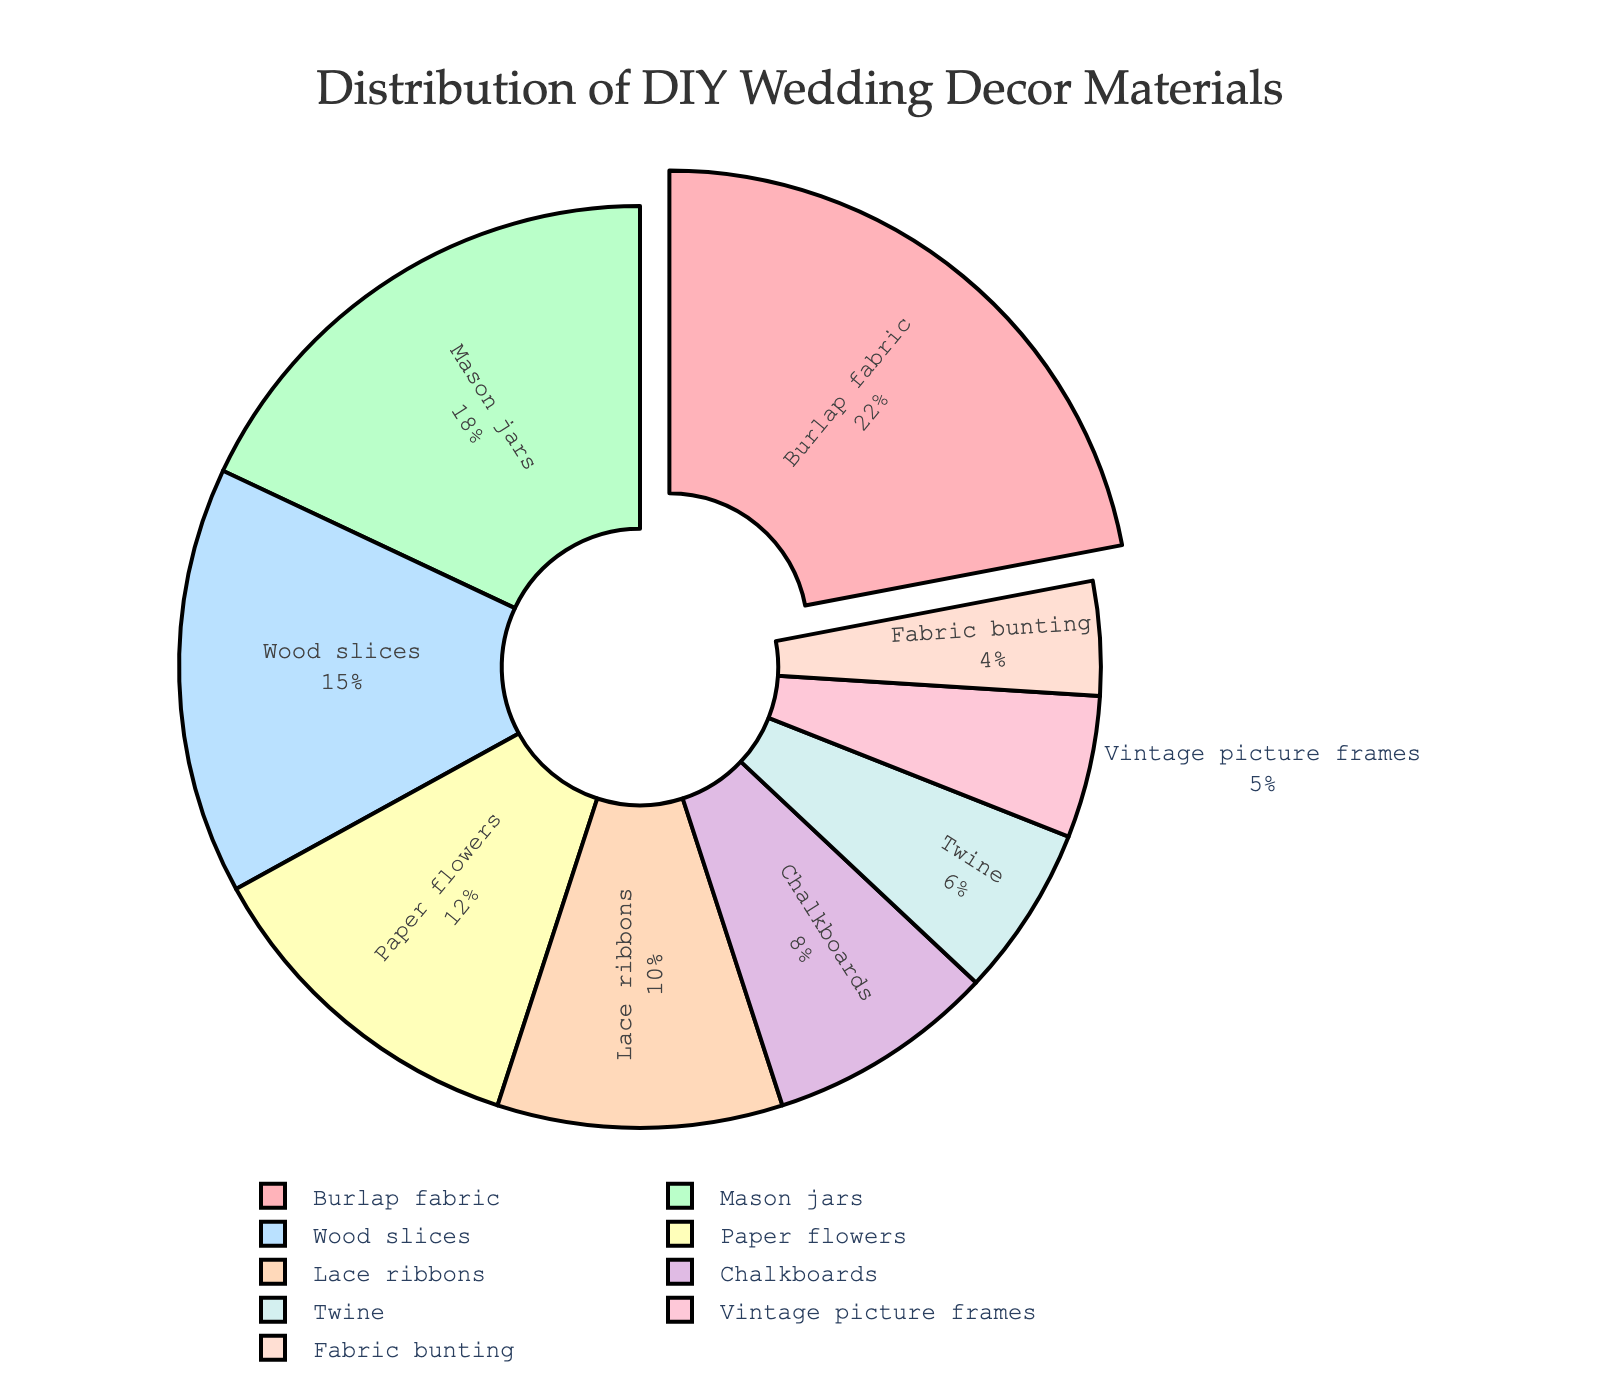What's the most popular DIY wedding decor material? The segment with the highest percentage represents the most popular material. The "Burlap fabric" segment is pulled outwards, indicating it’s the most used material with 22%.
Answer: Burlap fabric Which two materials together make up 30% of the distribution? Looking at the chart, "Mason jars" have 18% and "Twine" has 6%. Adding these percentages gives 24%, which is incorrect. Checking "Chalkboards" with 8% and "Twine" with 6%, together they have 14%, which is also incorrect. Now checking "Paper flowers" with 12% and "Lace ribbons" with 10%, these sum to 22%, incorrect. Finally, "Paper flowers" with 12% and "Fabric bunting" with 4%, they sum to 16%, incorrect. Checking "Wood slices" 15% + "Twine" 6% gives 21%, incorrect. Let's try "Lace ribbons" with 10% and "Vintage picture frames" with 5% gives 15%, not correct. Burlap 22% + Twine 6% summed is 28%, Lace ribbons 10% + Chalkboards 8% results in 18%, Wood slices 12% + Mason 18%, gives 30%, correct! So that's Wood slices and Mason jars.
Answer: Wood slices and Mason jars What material is used least frequently? The segment with the smallest percentage represents the least used material. "Fabric bunting" has the smallest segment at 4%.
Answer: Fabric bunting How much more popular are Mason jars compared to Twine? Mason jars have 18%, and Twine has 6%. The difference between them is 18% - 6% which equals 12%.
Answer: 12% Which materials have an equal share in the distribution? Comparing the labeled percentages, none of the materials have exactly the same percentage.
Answer: None If we combine the percentages of Chalkboards and Vintage picture frames, how does their total compare to the percentage of Paper flowers? Chalkboards have 8% and Vintage picture frames have 5%. Adding them together gives 8% + 5% = 13%. Comparing this to Paper flowers which has 12%, 13% is bigger than 12%.
Answer: 13% is greater What is the average percentage of usage among all materials? To find the average, we sum up all the percentages and divide by the number of materials. The total sum is 22 + 18 + 15 + 12 + 10 + 8 + 6 + 5 + 4 = 100. There are 9 materials. So, the average is 100 / 9 which is approximately 11.11%.
Answer: 11.11% Which materials combined make up more than 40% but less than 60%? Combining percentages to get a range: Burlap fabric (22%) + Mason jars (18%) gives 40%, adding Twine (6%) gives 46%. Burlap fabric (22%) + Chalkboards (8%) gives 30%, adding anything 30 fails. Mason jars (18%) + Wood slices (15%) is 33%, adding anything but more than 27%. So 46% fits the range, correct!
Answer: Burlap fabric, Mason jars, and Twine 